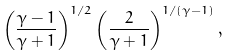<formula> <loc_0><loc_0><loc_500><loc_500>\left ( \frac { \gamma - 1 } { \gamma + 1 } \right ) ^ { 1 / 2 } \left ( \frac { 2 } { \gamma + 1 } \right ) ^ { 1 / ( \gamma - 1 ) } ,</formula> 